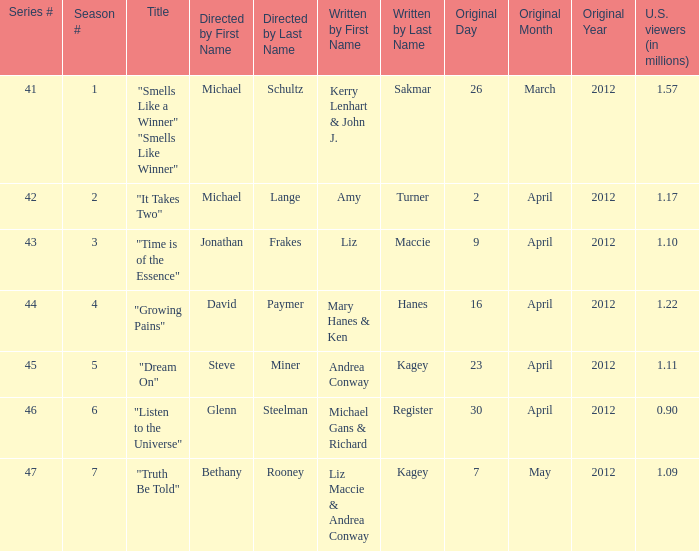When was the first broadcast of the episode titled "Truth Be Told"? May7,2012. 